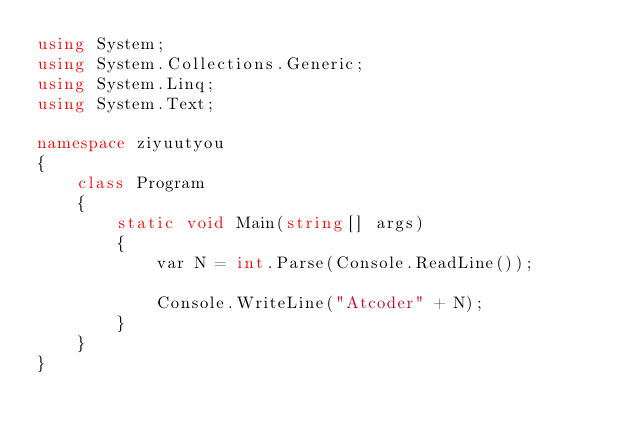Convert code to text. <code><loc_0><loc_0><loc_500><loc_500><_C#_>using System;
using System.Collections.Generic;
using System.Linq;
using System.Text;

namespace ziyuutyou
{
    class Program
    {
        static void Main(string[] args)
        {
            var N = int.Parse(Console.ReadLine());

            Console.WriteLine("Atcoder" + N);
        }
    }
}</code> 